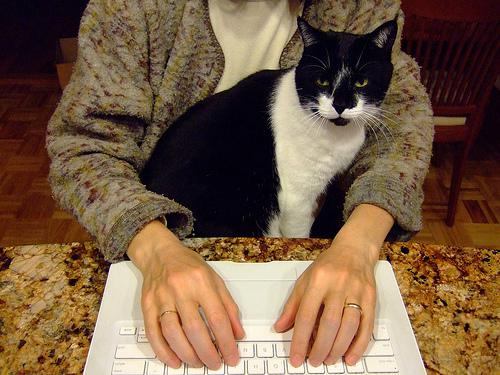Question: what color is the keyboard?
Choices:
A. Black.
B. Grey.
C. Blue.
D. White.
Answer with the letter. Answer: D Question: where is the person's fingers?
Choices:
A. In his pocket.
B. On the table.
C. On the keyboard.
D. In their mouth.
Answer with the letter. Answer: C Question: who is on the woman's lap?
Choices:
A. Her friend.
B. A dog.
C. A cat.
D. Rodent.
Answer with the letter. Answer: C Question: how many rings are the individuals hands?
Choices:
A. 2.
B. 1.
C. 0.
D. 3.
Answer with the letter. Answer: A 